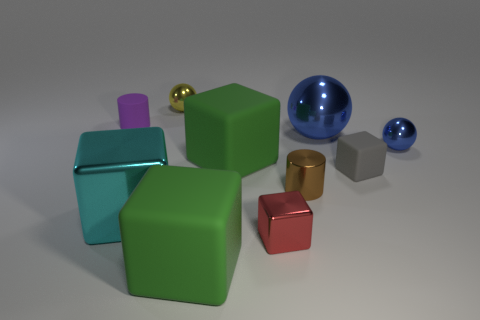Subtract all cyan cubes. How many cubes are left? 4 Subtract all red cubes. How many cubes are left? 4 Subtract all purple blocks. Subtract all purple balls. How many blocks are left? 5 Subtract all cylinders. How many objects are left? 8 Subtract 0 cyan spheres. How many objects are left? 10 Subtract all brown cylinders. Subtract all blue metal objects. How many objects are left? 7 Add 9 large cyan shiny things. How many large cyan shiny things are left? 10 Add 3 blue shiny cubes. How many blue shiny cubes exist? 3 